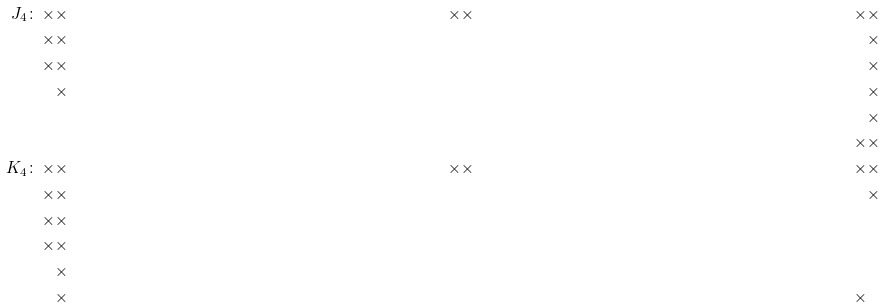<formula> <loc_0><loc_0><loc_500><loc_500>J _ { 4 } \colon \, \times & \times & \times & \times & \times & \times \\ \times & \times & & & & \times \\ \times & \times & & & & \times \\ & \times & & & & \times \\ & & & & & \times \\ & & & & \times & \times \\ \quad K _ { 4 } \colon \, \times & \times & \times & \times & \times & \times \\ \times & \times & & & & \times \\ \times & \times & & & & \\ \times & \times & & & & \\ & \times & & & & \\ & \times & & & \times & \\</formula> 